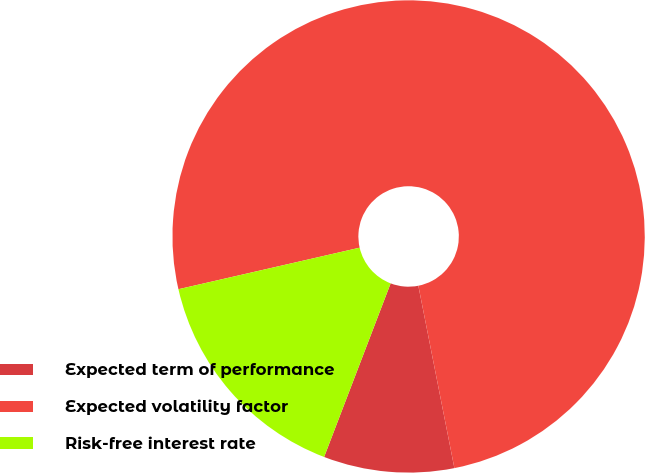<chart> <loc_0><loc_0><loc_500><loc_500><pie_chart><fcel>Expected term of performance<fcel>Expected volatility factor<fcel>Risk-free interest rate<nl><fcel>8.93%<fcel>75.48%<fcel>15.59%<nl></chart> 